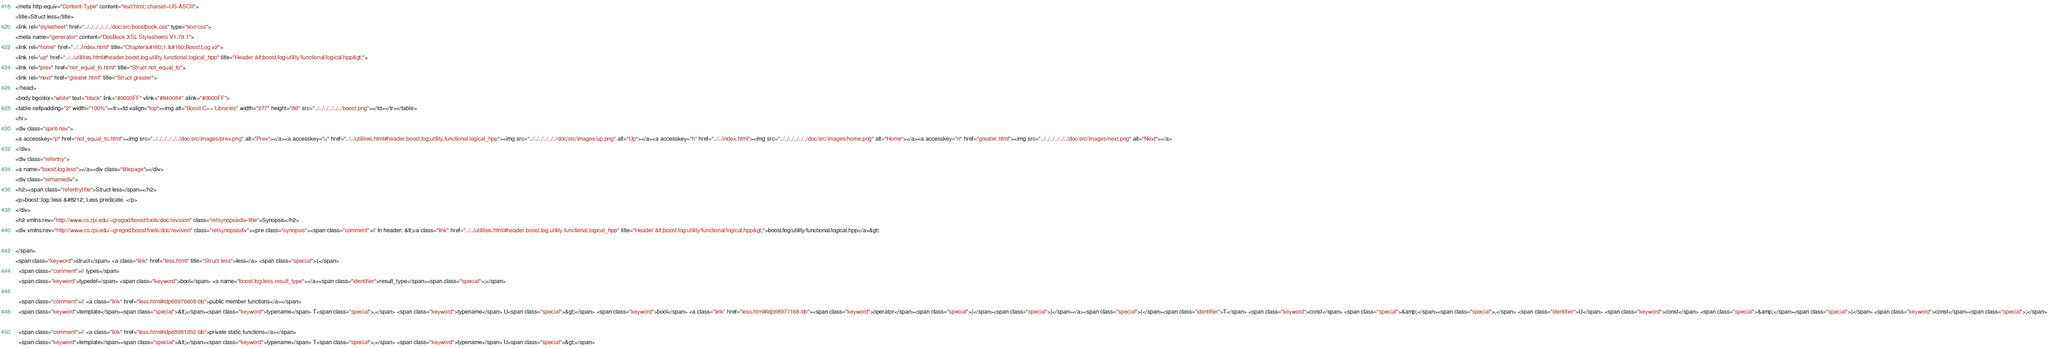Convert code to text. <code><loc_0><loc_0><loc_500><loc_500><_HTML_><meta http-equiv="Content-Type" content="text/html; charset=US-ASCII">
<title>Struct less</title>
<link rel="stylesheet" href="../../../../../../doc/src/boostbook.css" type="text/css">
<meta name="generator" content="DocBook XSL Stylesheets V1.79.1">
<link rel="home" href="../../index.html" title="Chapter&#160;1.&#160;Boost.Log v2">
<link rel="up" href="../../utilities.html#header.boost.log.utility.functional.logical_hpp" title="Header &lt;boost/log/utility/functional/logical.hpp&gt;">
<link rel="prev" href="not_equal_to.html" title="Struct not_equal_to">
<link rel="next" href="greater.html" title="Struct greater">
</head>
<body bgcolor="white" text="black" link="#0000FF" vlink="#840084" alink="#0000FF">
<table cellpadding="2" width="100%"><tr><td valign="top"><img alt="Boost C++ Libraries" width="277" height="86" src="../../../../../../boost.png"></td></tr></table>
<hr>
<div class="spirit-nav">
<a accesskey="p" href="not_equal_to.html"><img src="../../../../../../doc/src/images/prev.png" alt="Prev"></a><a accesskey="u" href="../../utilities.html#header.boost.log.utility.functional.logical_hpp"><img src="../../../../../../doc/src/images/up.png" alt="Up"></a><a accesskey="h" href="../../index.html"><img src="../../../../../../doc/src/images/home.png" alt="Home"></a><a accesskey="n" href="greater.html"><img src="../../../../../../doc/src/images/next.png" alt="Next"></a>
</div>
<div class="refentry">
<a name="boost.log.less"></a><div class="titlepage"></div>
<div class="refnamediv">
<h2><span class="refentrytitle">Struct less</span></h2>
<p>boost::log::less &#8212; Less predicate. </p>
</div>
<h2 xmlns:rev="http://www.cs.rpi.edu/~gregod/boost/tools/doc/revision" class="refsynopsisdiv-title">Synopsis</h2>
<div xmlns:rev="http://www.cs.rpi.edu/~gregod/boost/tools/doc/revision" class="refsynopsisdiv"><pre class="synopsis"><span class="comment">// In header: &lt;<a class="link" href="../../utilities.html#header.boost.log.utility.functional.logical_hpp" title="Header &lt;boost/log/utility/functional/logical.hpp&gt;">boost/log/utility/functional/logical.hpp</a>&gt;

</span>
<span class="keyword">struct</span> <a class="link" href="less.html" title="Struct less">less</a> <span class="special">{</span>
  <span class="comment">// types</span>
  <span class="keyword">typedef</span> <span class="keyword">bool</span> <a name="boost.log.less.result_type"></a><span class="identifier">result_type</span><span class="special">;</span>

  <span class="comment">// <a class="link" href="less.html#idp68976608-bb">public member functions</a></span>
  <span class="keyword">template</span><span class="special">&lt;</span><span class="keyword">typename</span> T<span class="special">,</span> <span class="keyword">typename</span> U<span class="special">&gt;</span> <span class="keyword">bool</span> <a class="link" href="less.html#idp68977168-bb"><span class="keyword">operator</span><span class="special">(</span><span class="special">)</span></a><span class="special">(</span><span class="identifier">T</span> <span class="keyword">const</span> <span class="special">&amp;</span><span class="special">,</span> <span class="identifier">U</span> <span class="keyword">const</span> <span class="special">&amp;</span><span class="special">)</span> <span class="keyword">const</span><span class="special">;</span>

  <span class="comment">// <a class="link" href="less.html#idp68981232-bb">private static functions</a></span>
  <span class="keyword">template</span><span class="special">&lt;</span><span class="keyword">typename</span> T<span class="special">,</span> <span class="keyword">typename</span> U<span class="special">&gt;</span> </code> 